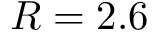<formula> <loc_0><loc_0><loc_500><loc_500>R = 2 . 6</formula> 